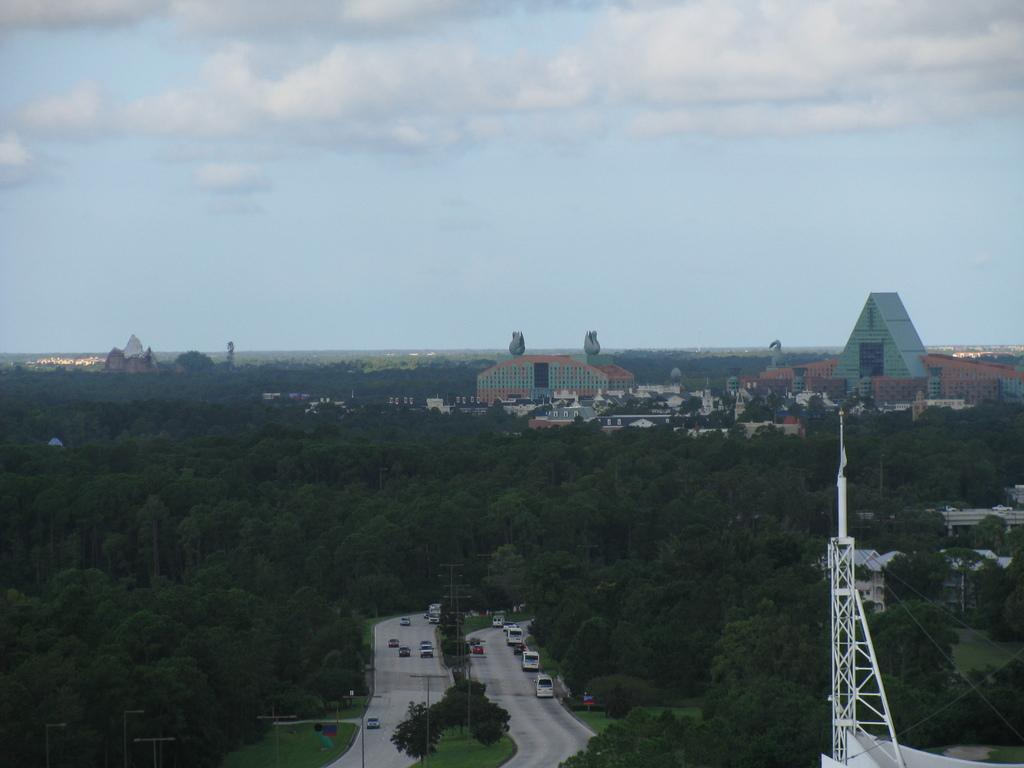What is happening on the road in the image? There are vehicles moving on the road in the image. What structures can be seen along the road? There are street light poles in the image. What type of natural elements are present in the image? Trees are present in the image. What type of man-made structures are visible in the image? There are towers and buildings visible in the image. How would you describe the weather in the image? The sky in the background is cloudy. What type of arch can be seen in the image? There is no arch present in the image. What kind of tin is being used to store the feast in the image? There is no feast or tin present in the image. 